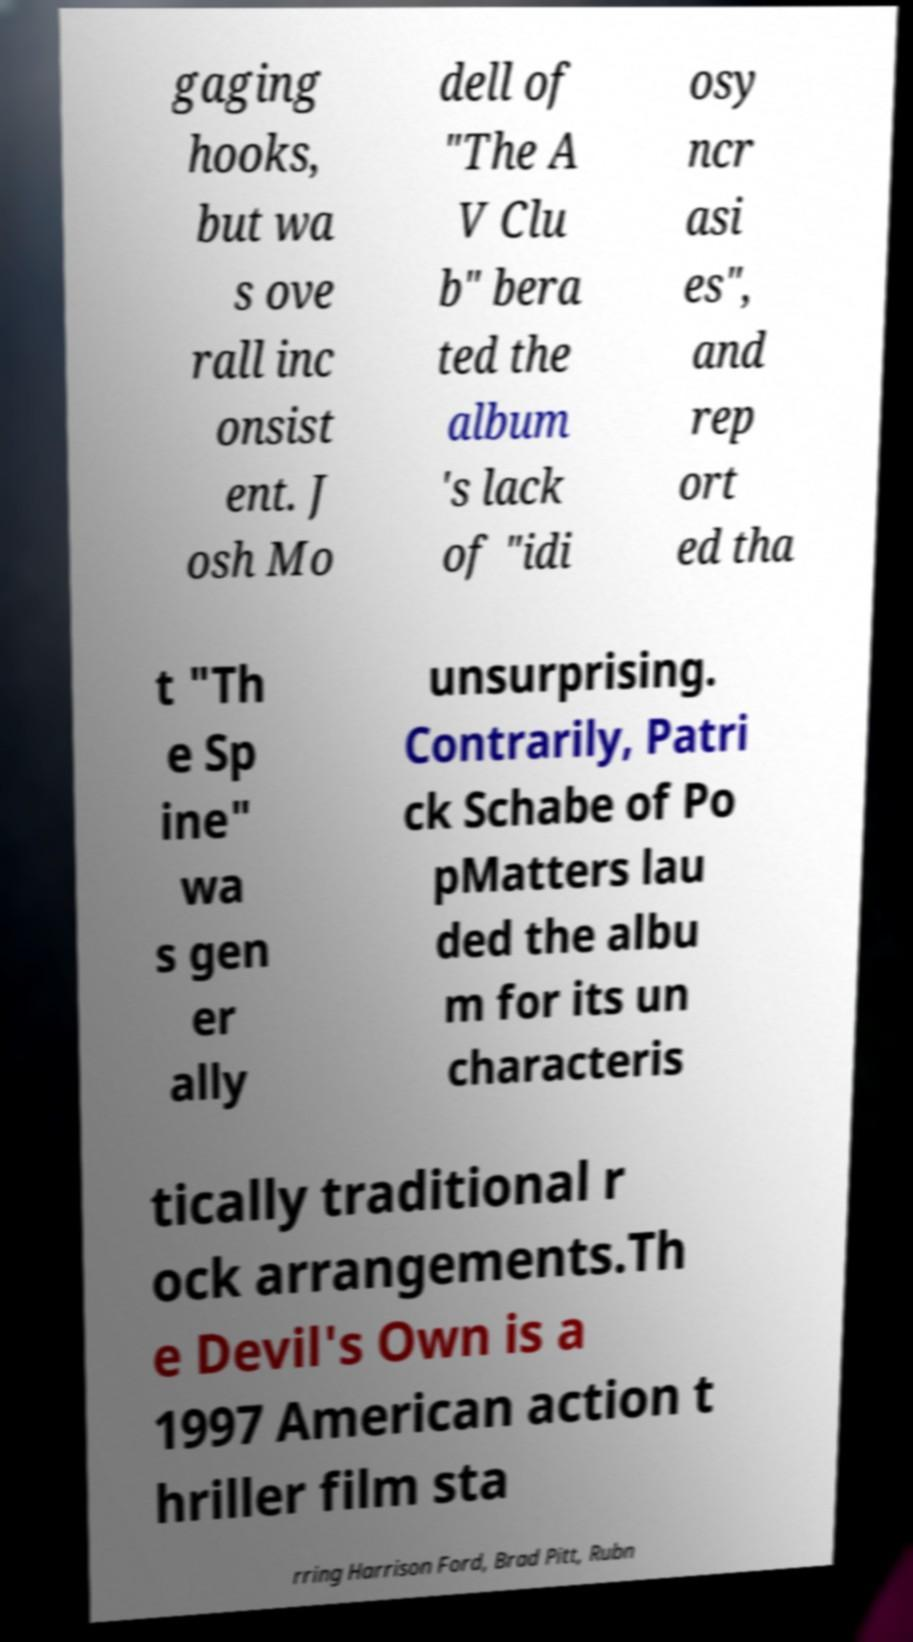There's text embedded in this image that I need extracted. Can you transcribe it verbatim? gaging hooks, but wa s ove rall inc onsist ent. J osh Mo dell of "The A V Clu b" bera ted the album 's lack of "idi osy ncr asi es", and rep ort ed tha t "Th e Sp ine" wa s gen er ally unsurprising. Contrarily, Patri ck Schabe of Po pMatters lau ded the albu m for its un characteris tically traditional r ock arrangements.Th e Devil's Own is a 1997 American action t hriller film sta rring Harrison Ford, Brad Pitt, Rubn 